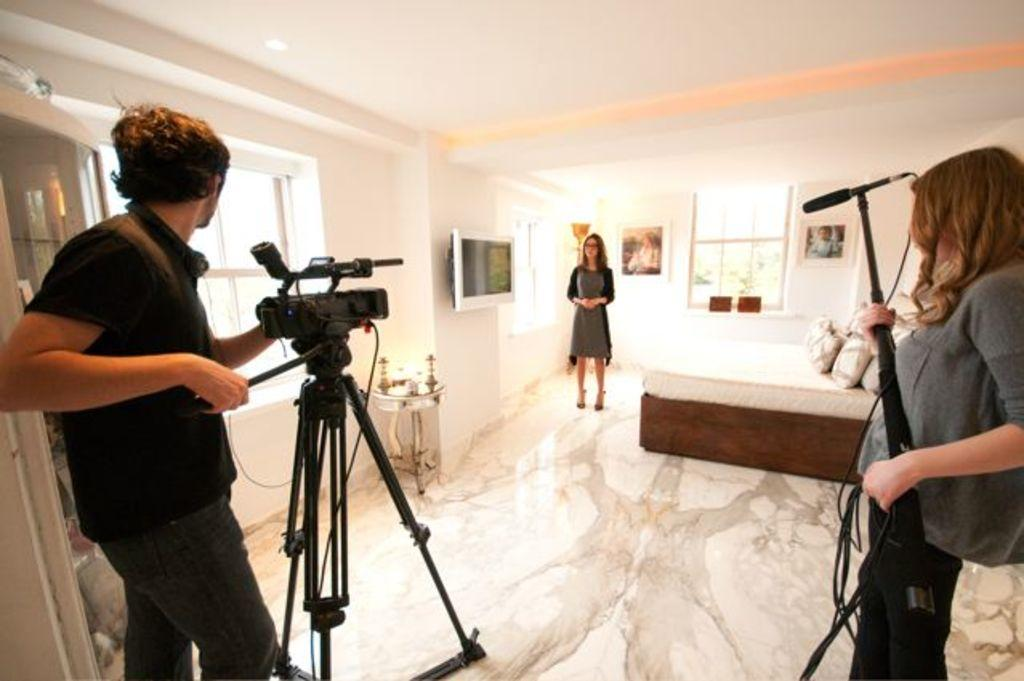What is the man on the left side of the image holding? The man is holding a camera. What is the man wearing in the image? The man is wearing a black t-shirt. What is the woman in the middle of the image doing? There is no specific action mentioned for the woman in the middle, but she is standing there. What is the woman on the right side of the image holding? The woman on the right side is holding a microphone. What type of bun is the man eating in the image? There is no bun present in the image; the man is holding a camera. How many legs does the microphone have in the image? The microphone is an object and does not have legs; it is held by the woman on the right side of the image. 